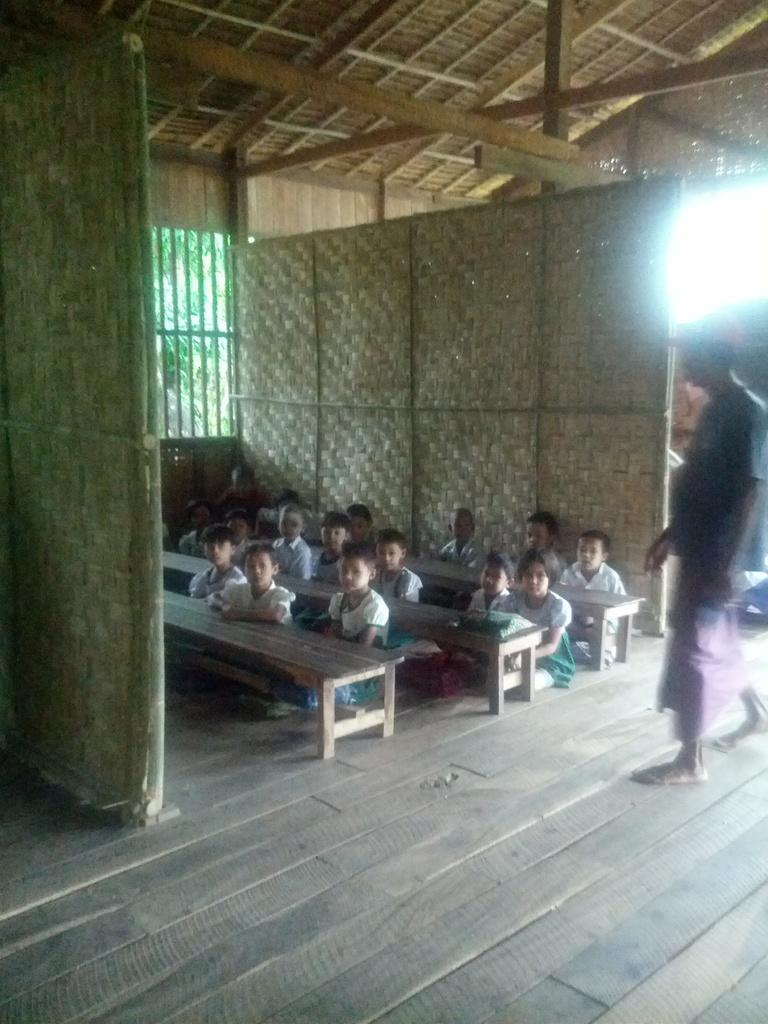How many people are in the image? There is a group of people in the image. What are some of the people doing in the image? Some of the people are seated, and one person is walking. What are the seated people sitting on? There are benches in front of the seated people. What can be seen in the background of the image? There are trees in the background of the image. What flavor of ice cream is the person walking in the image eating? There is no ice cream present in the image, so it is not possible to determine the flavor. 